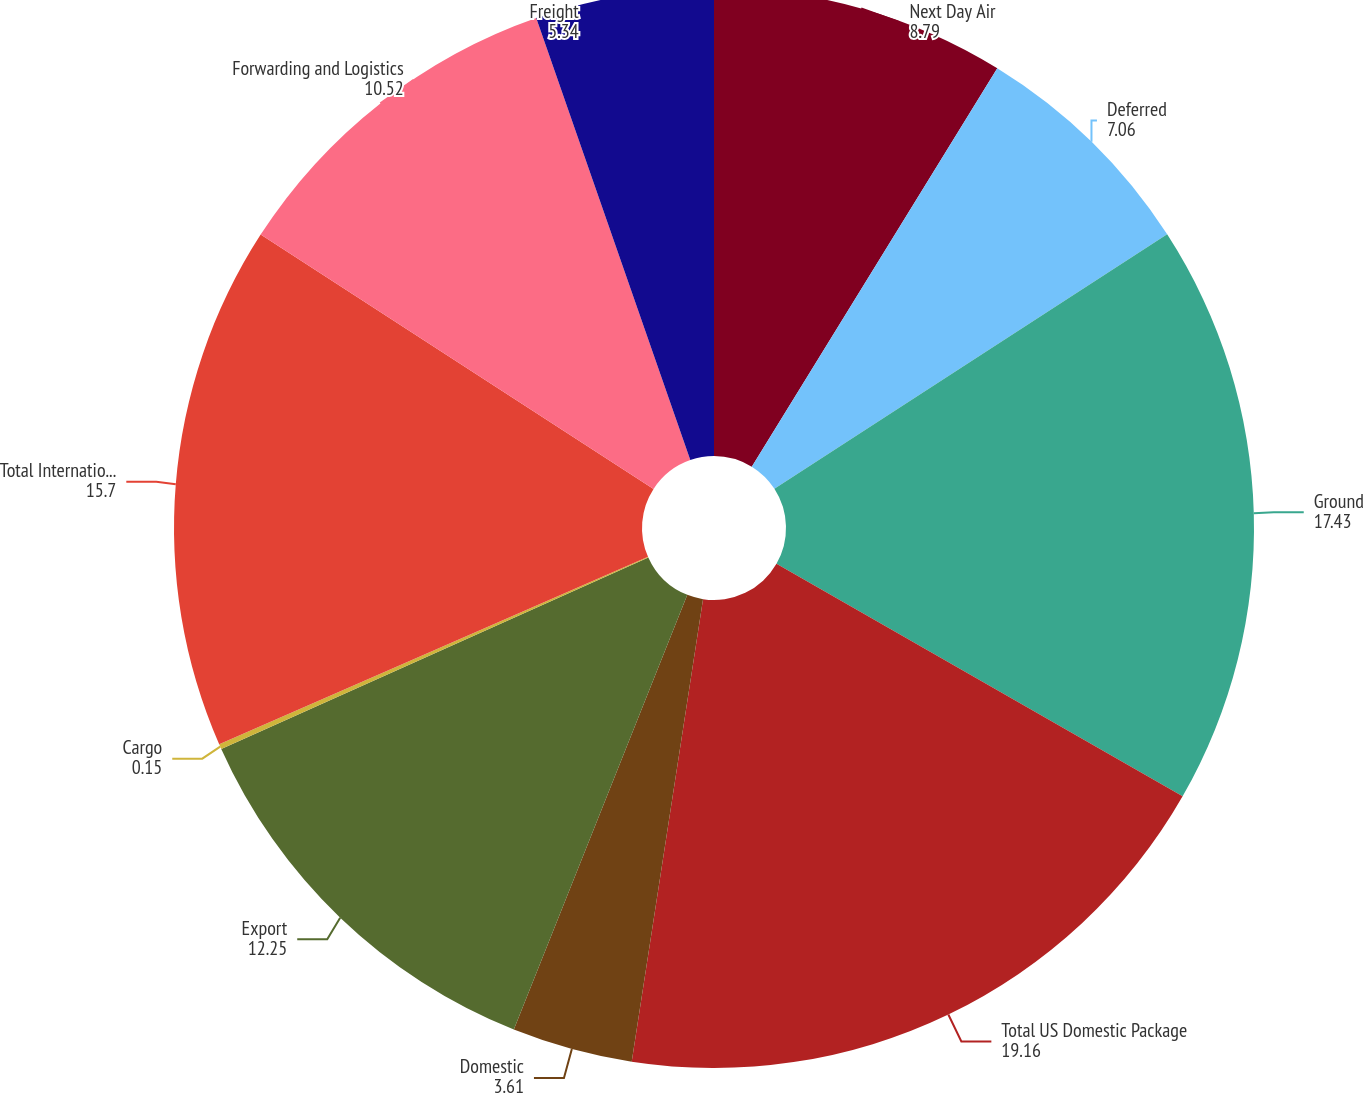Convert chart to OTSL. <chart><loc_0><loc_0><loc_500><loc_500><pie_chart><fcel>Next Day Air<fcel>Deferred<fcel>Ground<fcel>Total US Domestic Package<fcel>Domestic<fcel>Export<fcel>Cargo<fcel>Total International Package<fcel>Forwarding and Logistics<fcel>Freight<nl><fcel>8.79%<fcel>7.06%<fcel>17.43%<fcel>19.16%<fcel>3.61%<fcel>12.25%<fcel>0.15%<fcel>15.7%<fcel>10.52%<fcel>5.34%<nl></chart> 